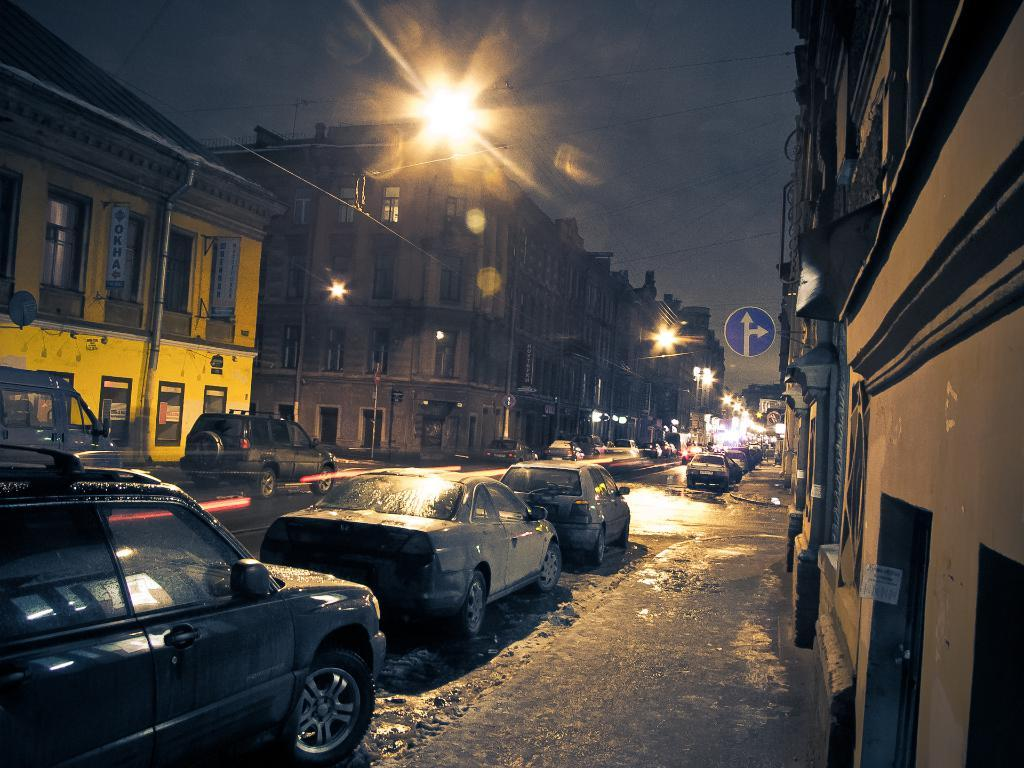What type of structures can be seen in the image? There are buildings in the image. What are the vertical poles in the image used for? Street poles are present in the image. What type of signs can be seen in the image? Sign boards are visible in the image. What infrastructure is present in the image? Pipelines are in the image. What type of boards provide information in the image? Information boards are present in the image. What type of vehicles are on the road in the image? Motor vehicles are on the road in the image. What type of lighting is visible in the image? Electric lights are visible in the image. What part of the natural environment is visible in the image? The sky is visible in the image. What type of railway is depicted in the image? There is no railway present in the image. What message of peace and love can be seen on the sign boards in the image? The image does not contain any messages of peace or love; it features sign boards with other types of information. 